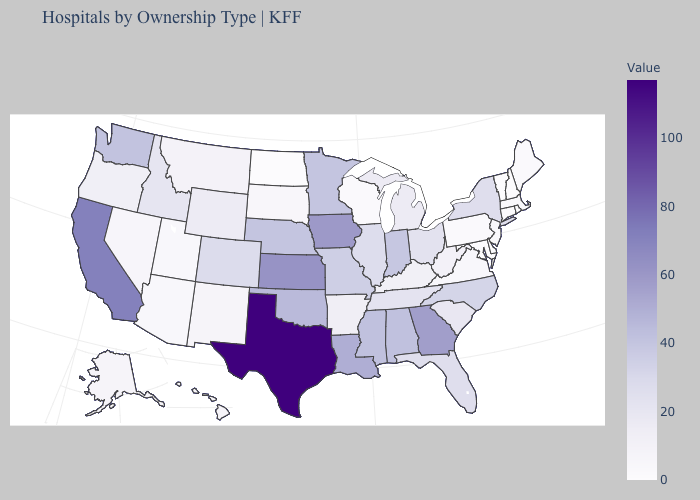Among the states that border Delaware , which have the highest value?
Answer briefly. New Jersey. Which states have the lowest value in the USA?
Be succinct. Delaware, Maryland, New Hampshire, North Dakota, Rhode Island, Vermont. Does Mississippi have a higher value than Georgia?
Concise answer only. No. Which states hav the highest value in the West?
Be succinct. California. Among the states that border West Virginia , does Virginia have the lowest value?
Be succinct. No. Which states have the highest value in the USA?
Be succinct. Texas. 